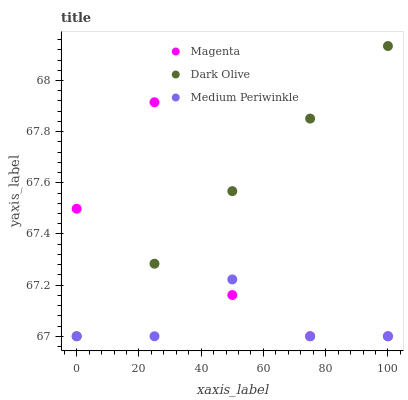Does Medium Periwinkle have the minimum area under the curve?
Answer yes or no. Yes. Does Dark Olive have the maximum area under the curve?
Answer yes or no. Yes. Does Dark Olive have the minimum area under the curve?
Answer yes or no. No. Does Medium Periwinkle have the maximum area under the curve?
Answer yes or no. No. Is Dark Olive the smoothest?
Answer yes or no. Yes. Is Magenta the roughest?
Answer yes or no. Yes. Is Medium Periwinkle the smoothest?
Answer yes or no. No. Is Medium Periwinkle the roughest?
Answer yes or no. No. Does Magenta have the lowest value?
Answer yes or no. Yes. Does Dark Olive have the highest value?
Answer yes or no. Yes. Does Medium Periwinkle have the highest value?
Answer yes or no. No. Does Medium Periwinkle intersect Dark Olive?
Answer yes or no. Yes. Is Medium Periwinkle less than Dark Olive?
Answer yes or no. No. Is Medium Periwinkle greater than Dark Olive?
Answer yes or no. No. 